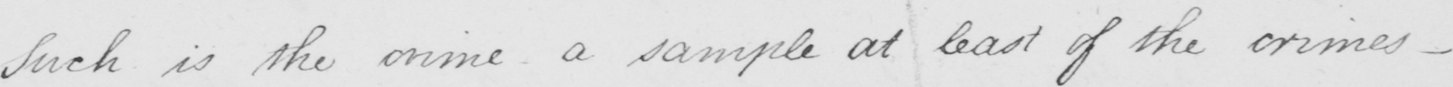Please provide the text content of this handwritten line. Such is the crime a sample at least of the crimes  _ 